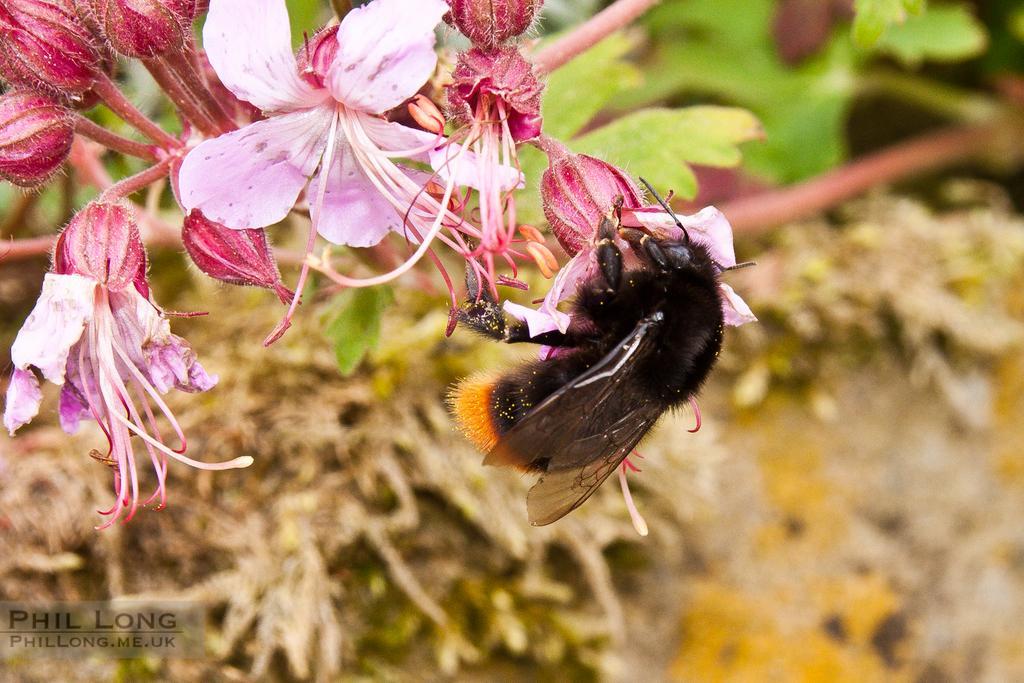Please provide a concise description of this image. This image is taken outdoors. This image is an edited image. In the background there are a few plants. In the middle of the image there is a honey bee on the flower and there are a few flowers and buds. 